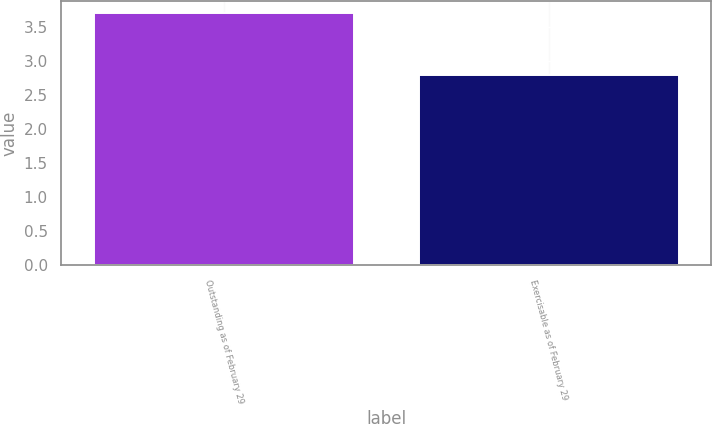Convert chart. <chart><loc_0><loc_0><loc_500><loc_500><bar_chart><fcel>Outstanding as of February 29<fcel>Exercisable as of February 29<nl><fcel>3.7<fcel>2.8<nl></chart> 